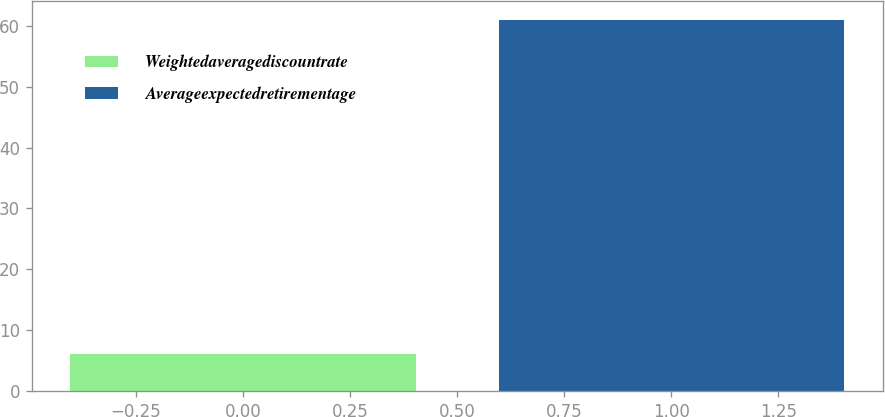Convert chart to OTSL. <chart><loc_0><loc_0><loc_500><loc_500><bar_chart><fcel>Weightedaveragediscountrate<fcel>Averageexpectedretirementage<nl><fcel>6<fcel>61<nl></chart> 